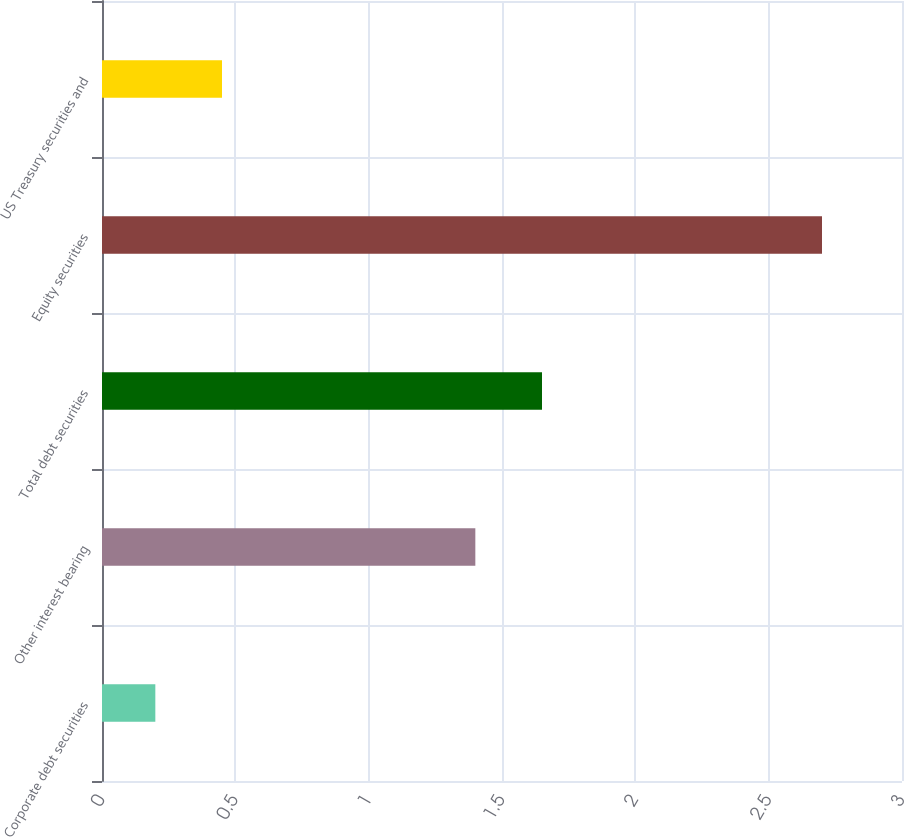<chart> <loc_0><loc_0><loc_500><loc_500><bar_chart><fcel>Corporate debt securities<fcel>Other interest bearing<fcel>Total debt securities<fcel>Equity securities<fcel>US Treasury securities and<nl><fcel>0.2<fcel>1.4<fcel>1.65<fcel>2.7<fcel>0.45<nl></chart> 